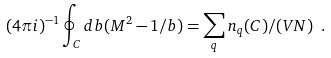Convert formula to latex. <formula><loc_0><loc_0><loc_500><loc_500>( 4 \pi i ) ^ { - 1 } \oint _ { C } d b ( M ^ { 2 } - 1 / b ) = \sum _ { q } n _ { q } ( C ) / ( V N ) \ .</formula> 